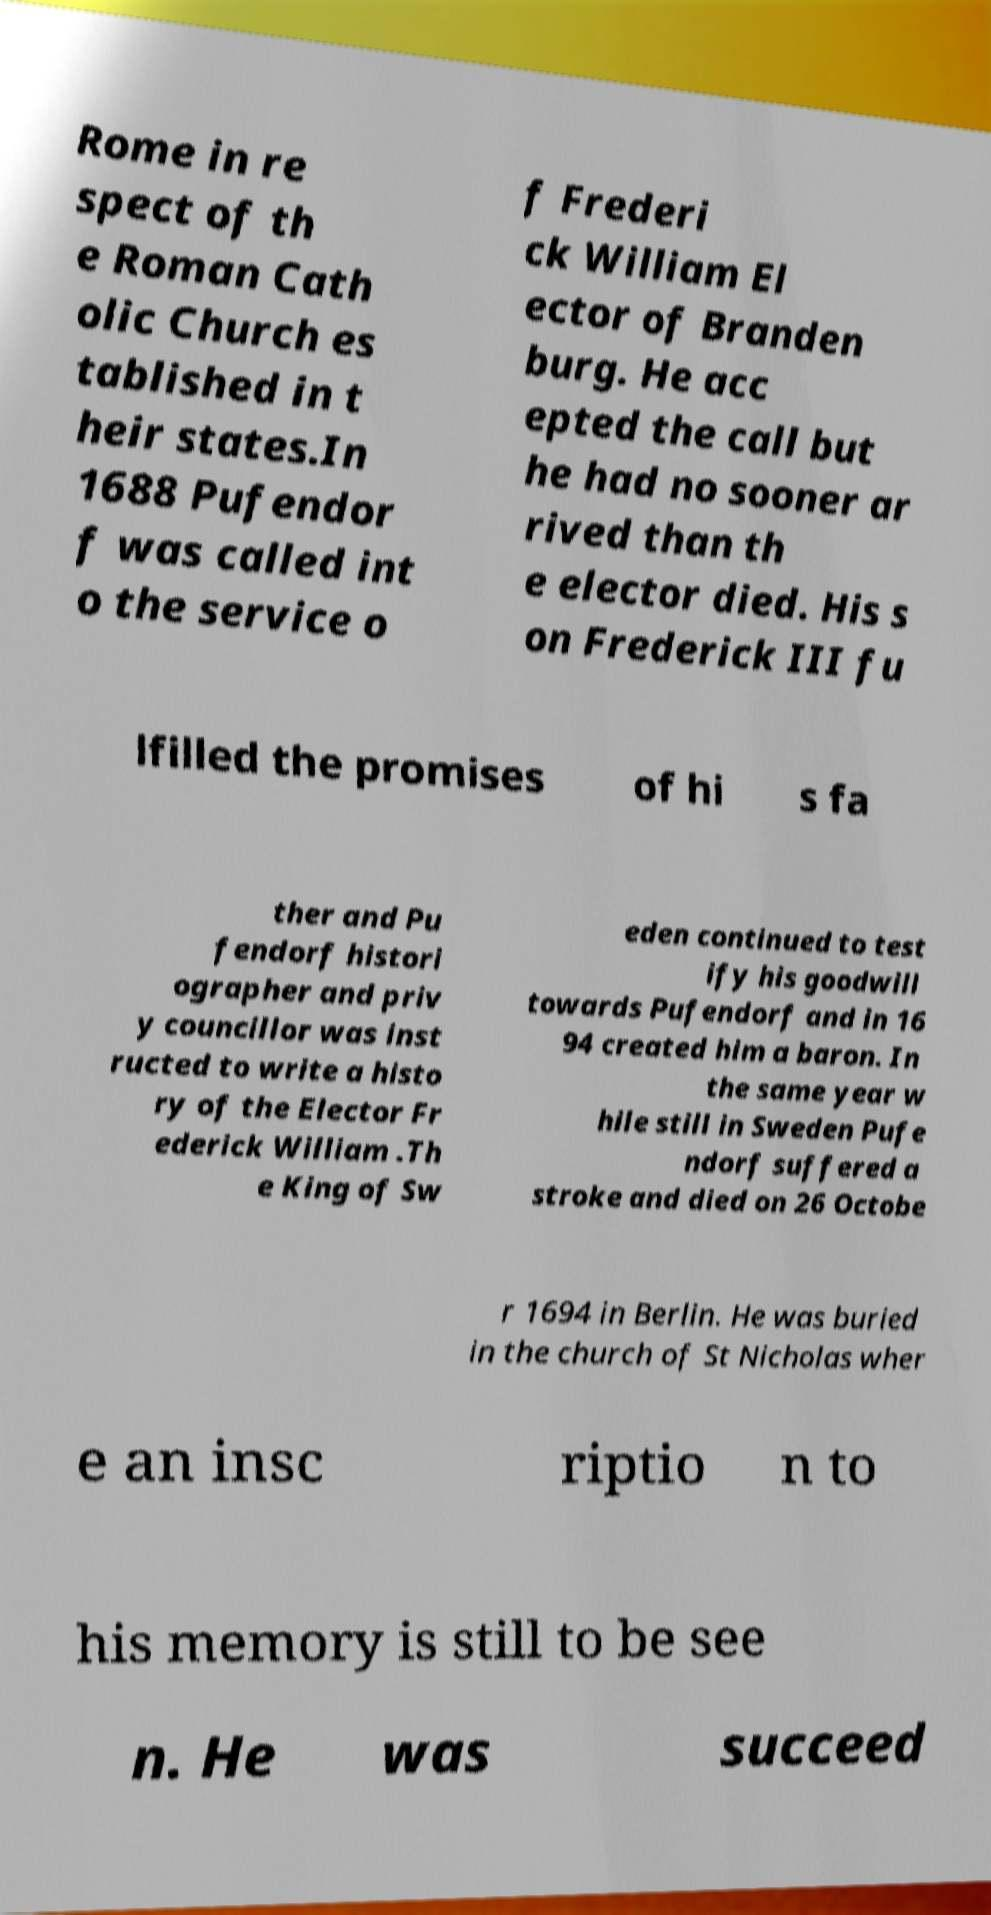I need the written content from this picture converted into text. Can you do that? Rome in re spect of th e Roman Cath olic Church es tablished in t heir states.In 1688 Pufendor f was called int o the service o f Frederi ck William El ector of Branden burg. He acc epted the call but he had no sooner ar rived than th e elector died. His s on Frederick III fu lfilled the promises of hi s fa ther and Pu fendorf histori ographer and priv y councillor was inst ructed to write a histo ry of the Elector Fr ederick William .Th e King of Sw eden continued to test ify his goodwill towards Pufendorf and in 16 94 created him a baron. In the same year w hile still in Sweden Pufe ndorf suffered a stroke and died on 26 Octobe r 1694 in Berlin. He was buried in the church of St Nicholas wher e an insc riptio n to his memory is still to be see n. He was succeed 